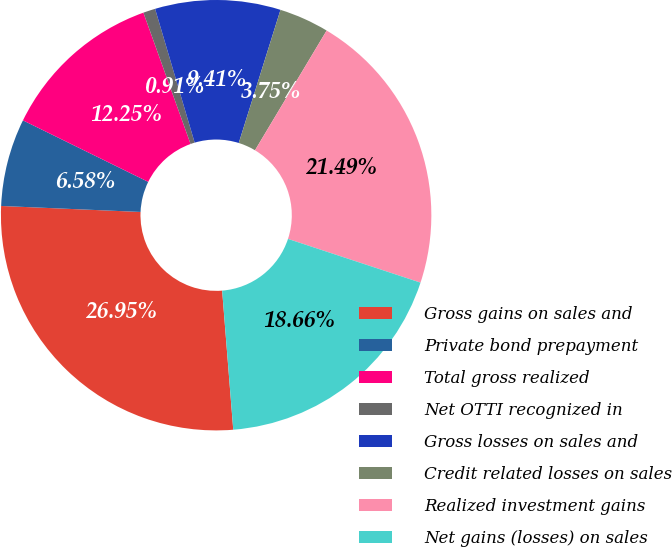Convert chart. <chart><loc_0><loc_0><loc_500><loc_500><pie_chart><fcel>Gross gains on sales and<fcel>Private bond prepayment<fcel>Total gross realized<fcel>Net OTTI recognized in<fcel>Gross losses on sales and<fcel>Credit related losses on sales<fcel>Realized investment gains<fcel>Net gains (losses) on sales<nl><fcel>26.95%<fcel>6.58%<fcel>12.25%<fcel>0.91%<fcel>9.41%<fcel>3.75%<fcel>21.49%<fcel>18.66%<nl></chart> 